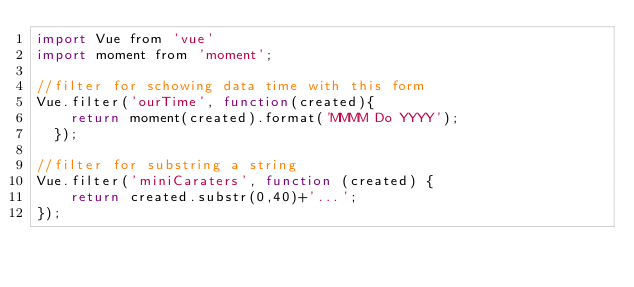<code> <loc_0><loc_0><loc_500><loc_500><_JavaScript_>import Vue from 'vue'
import moment from 'moment';

//filter for schowing data time with this form
Vue.filter('ourTime', function(created){
    return moment(created).format('MMMM Do YYYY');
  });

//filter for substring a string
Vue.filter('miniCaraters', function (created) {
    return created.substr(0,40)+'...';
});

</code> 